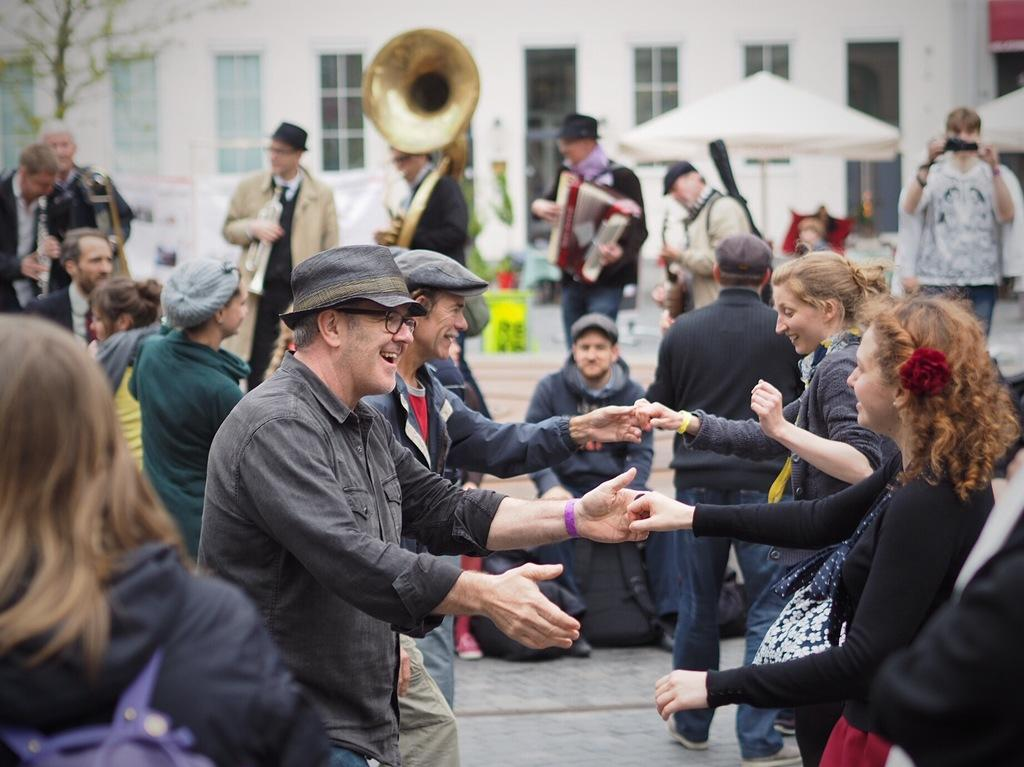What are the people in the image doing? The people in the image are standing and playing musical instruments. Can you describe the background of the image? There are buildings visible in the background of the image. What type of health benefits can be gained from the zephyr in the image? There is no zephyr present in the image, so it is not possible to discuss any health benefits associated with it. 